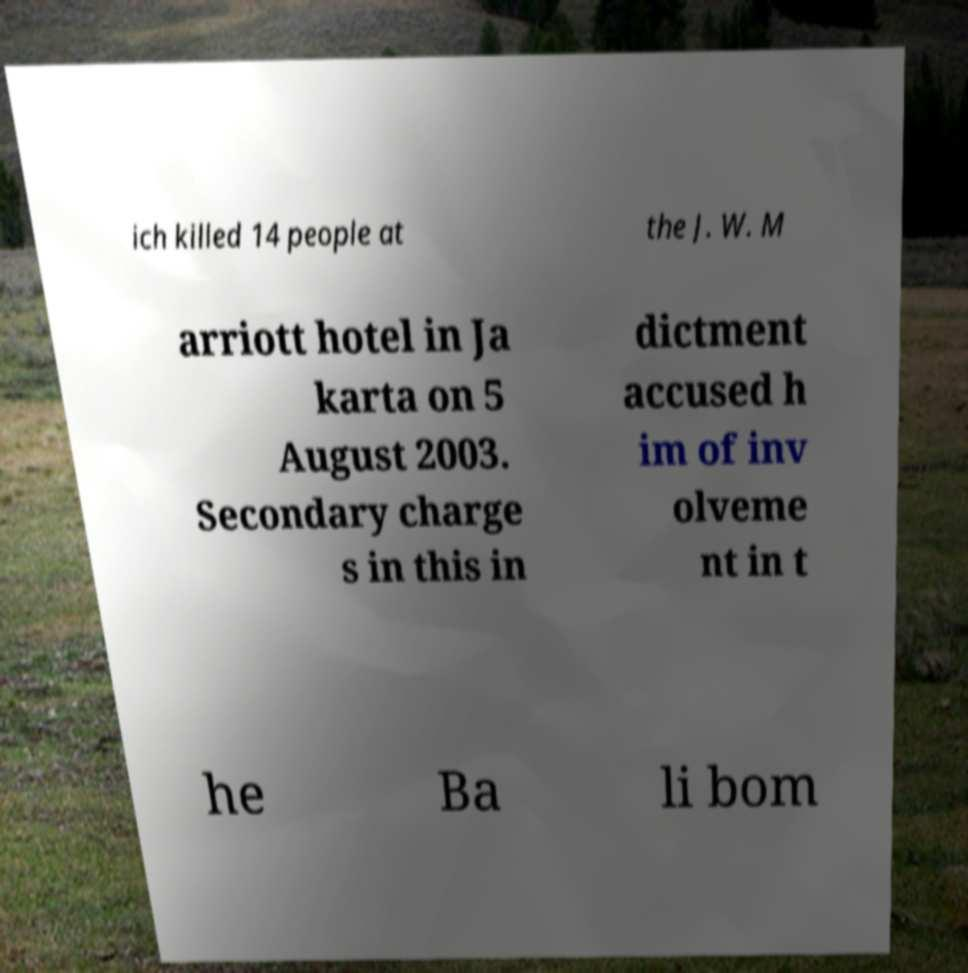Please read and relay the text visible in this image. What does it say? ich killed 14 people at the J. W. M arriott hotel in Ja karta on 5 August 2003. Secondary charge s in this in dictment accused h im of inv olveme nt in t he Ba li bom 